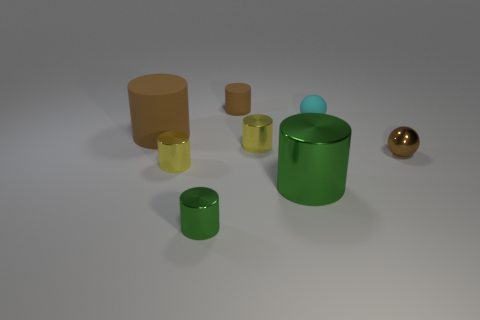Subtract all green cylinders. How many cylinders are left? 4 Subtract all big brown cylinders. How many cylinders are left? 5 Subtract all blue cylinders. Subtract all yellow blocks. How many cylinders are left? 6 Add 1 brown rubber cylinders. How many objects exist? 9 Subtract all cylinders. How many objects are left? 2 Subtract all tiny rubber balls. Subtract all large rubber cylinders. How many objects are left? 6 Add 2 big brown objects. How many big brown objects are left? 3 Add 8 big purple rubber objects. How many big purple rubber objects exist? 8 Subtract 0 blue cylinders. How many objects are left? 8 